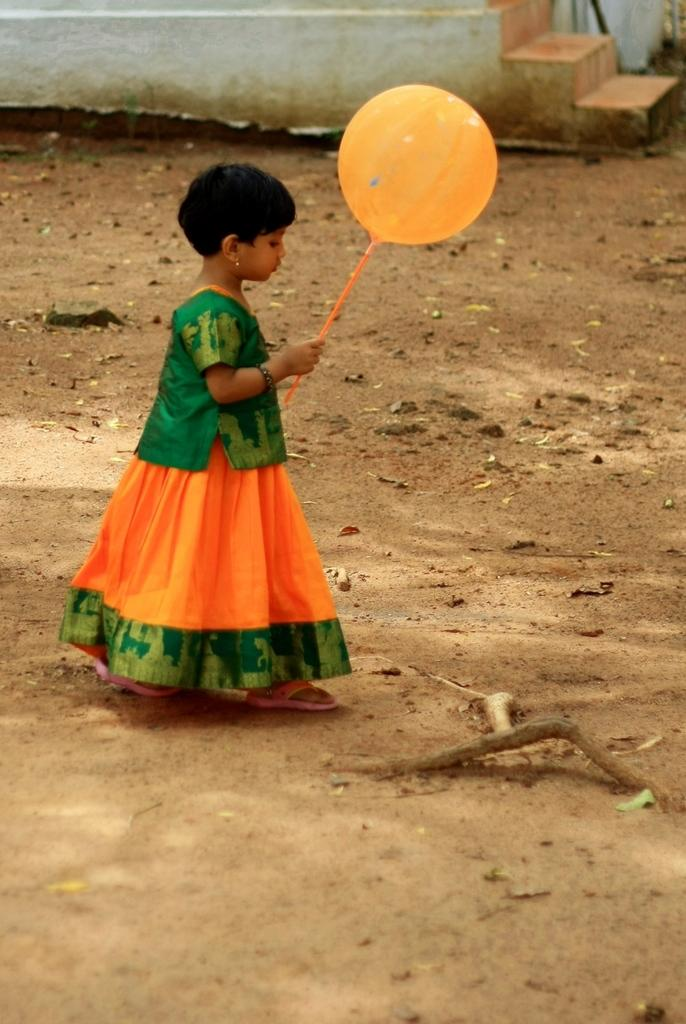Who is the main subject in the image? There is a girl in the image. What is the girl doing in the image? The girl is walking on the road. What is the girl holding in the image? The girl is holding a balloon. What can be seen in the background of the image? There are stairs visible in the background of the image. How many lifts has the girl experienced in the image? There is no mention of lifts in the image, so it is not possible to determine how many lifts the girl has experienced. 